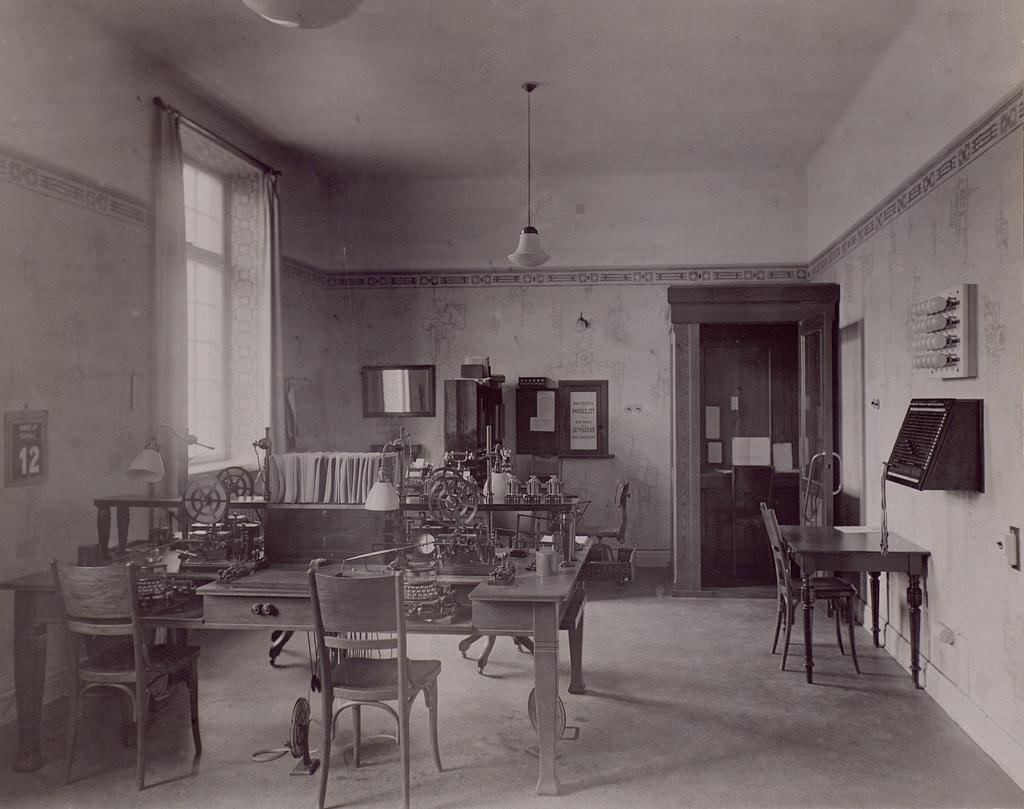Can you describe this image briefly? This image is taken inside the room. In this image we can see the tables, chairs, lamps, framed, mirror and also calendar attached to the wall. On the right we can see the lights to the board. We can also see the window with the curtain. At the top there is ceiling with the light and at the bottom there is floor. 